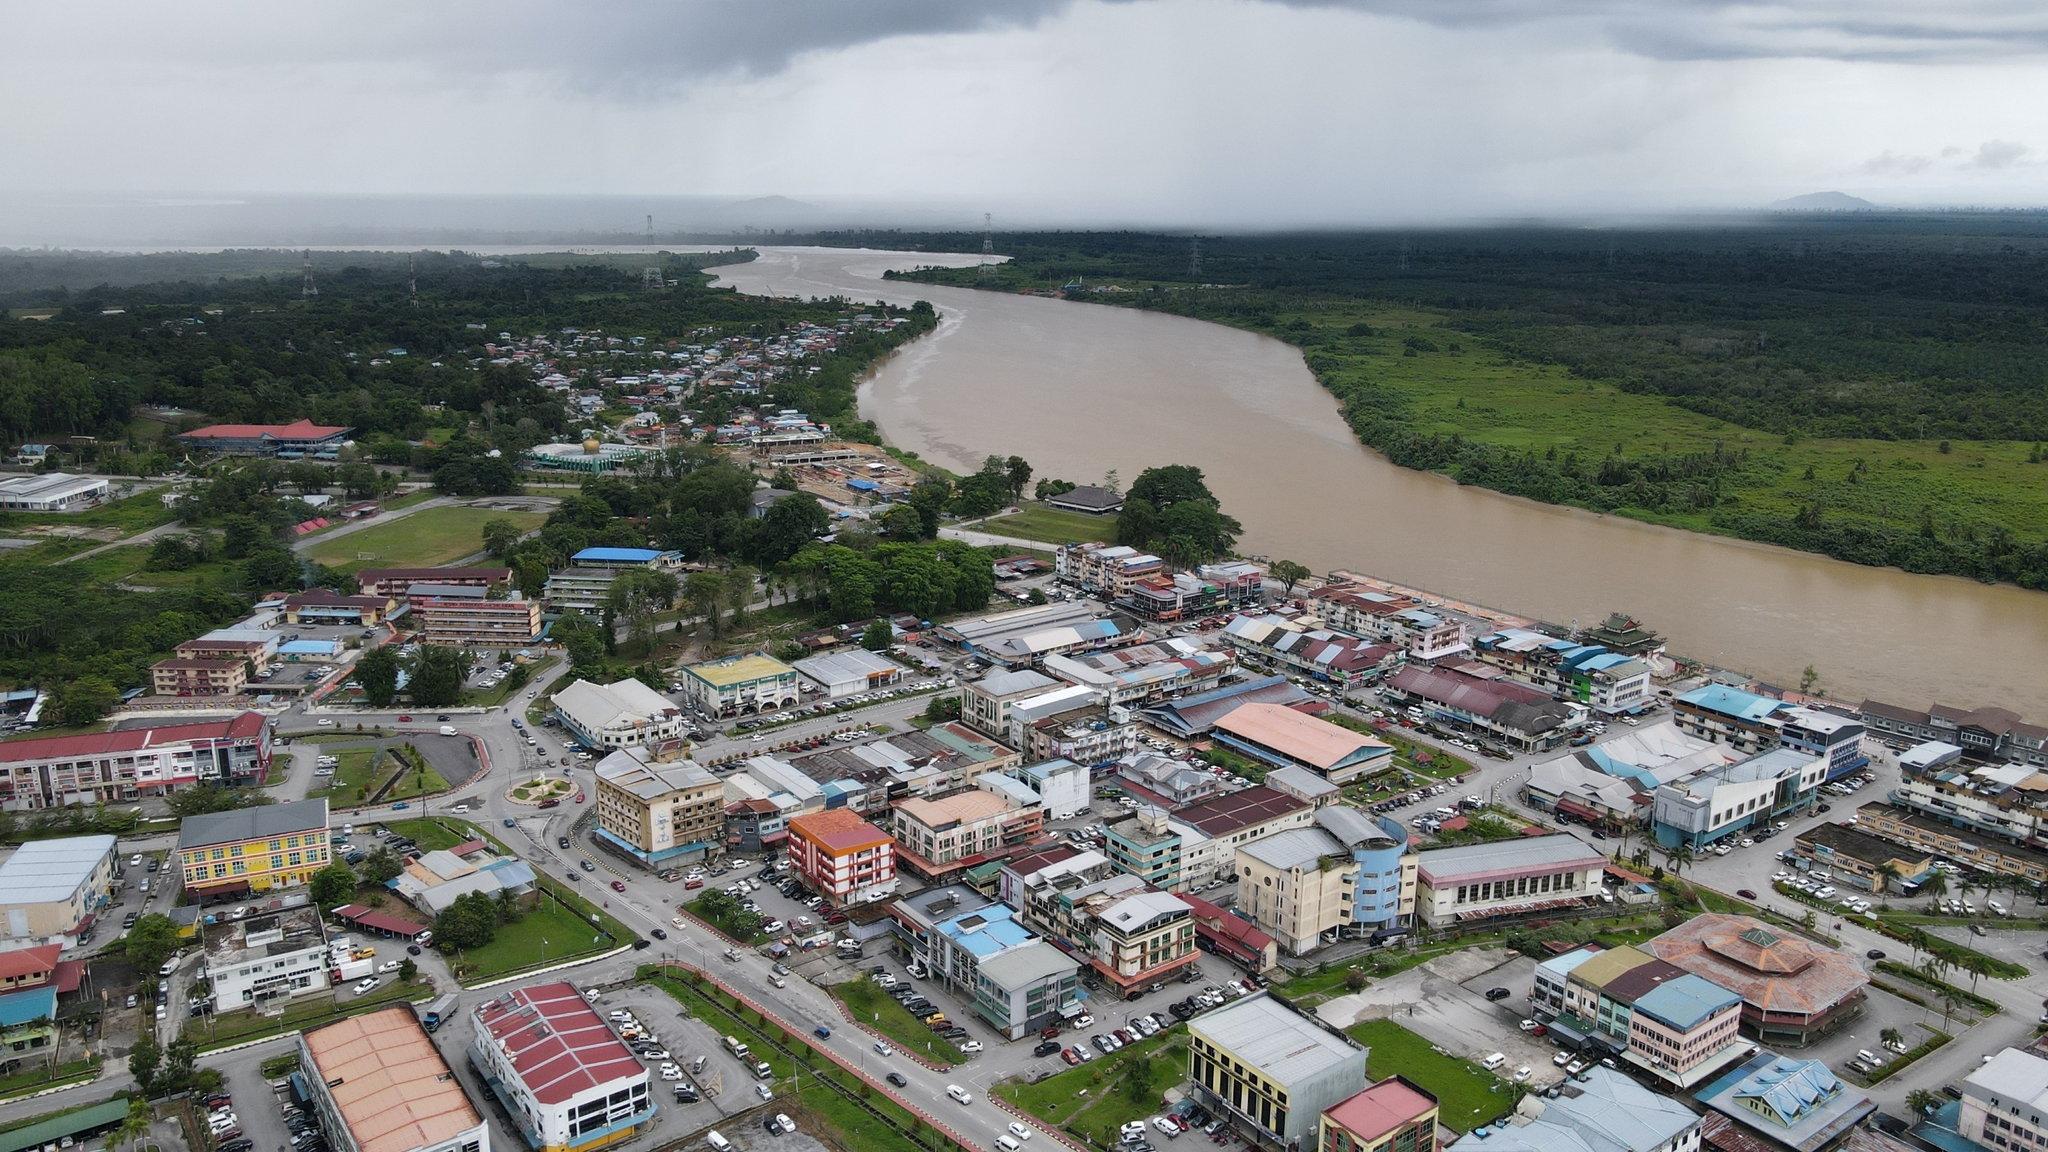What daily challenges might residents of this town face? Residents of this town might face several daily challenges typical of urban environments. Traffic congestion could be a significant issue as many people commute to work, school, or markets, leading to delays and increased air pollution. Ensuring access to clean water and reliable electricity might also pose challenges, especially during extreme weather events like heavy rains or storms that can disrupt utilities. Economic constraints could affect some families, with limited job opportunities or fluctuating market conditions impacting household incomes. Additionally, healthcare accessibility might present difficulties, particularly for those living in more remote parts of the town or for elderly residents requiring regular medical attention. Safety concerns, such as petty crime and the need for effective law enforcement, add another layer of daily stress for the community. Despite these challenges, the town's strong sense of community and collective resilience often help in finding local solutions and support systems to address these issues. 